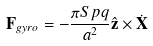<formula> <loc_0><loc_0><loc_500><loc_500>\mathbf F _ { g y r o } = - \frac { \pi S p q } { a ^ { 2 } } \hat { \mathbf z } \times \dot { \mathbf X }</formula> 